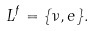Convert formula to latex. <formula><loc_0><loc_0><loc_500><loc_500>L ^ { f } = \{ \nu , e \} .</formula> 